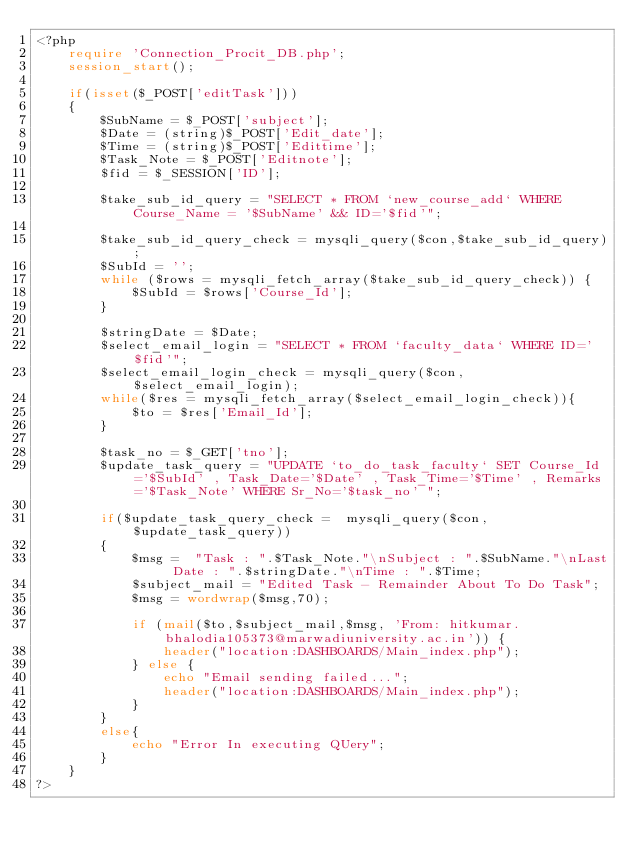Convert code to text. <code><loc_0><loc_0><loc_500><loc_500><_PHP_><?php
	require 'Connection_Procit_DB.php'; 
    session_start();

    if(isset($_POST['editTask']))
    {
    	$SubName = $_POST['subject'];
    	$Date = (string)$_POST['Edit_date'];
        $Time = (string)$_POST['Edittime'];
        $Task_Note = $_POST['Editnote'];
        $fid = $_SESSION['ID'];

        $take_sub_id_query = "SELECT * FROM `new_course_add` WHERE Course_Name = '$SubName' && ID='$fid'";

        $take_sub_id_query_check = mysqli_query($con,$take_sub_id_query);
        $SubId = '';
        while ($rows = mysqli_fetch_array($take_sub_id_query_check)) {
            $SubId = $rows['Course_Id'];
        }
        
        $stringDate = $Date;
        $select_email_login = "SELECT * FROM `faculty_data` WHERE ID='$fid'";
        $select_email_login_check = mysqli_query($con,$select_email_login);
        while($res = mysqli_fetch_array($select_email_login_check)){
            $to = $res['Email_Id'];
        }

        $task_no = $_GET['tno'];
    	$update_task_query = "UPDATE `to_do_task_faculty` SET Course_Id='$SubId' , Task_Date='$Date' , Task_Time='$Time' , Remarks='$Task_Note' WHERE Sr_No='$task_no' ";

    	if($update_task_query_check =  mysqli_query($con,$update_task_query))
    	{
            $msg =  "Task : ".$Task_Note."\nSubject : ".$SubName."\nLast Date : ".$stringDate."\nTime : ".$Time; 
            $subject_mail = "Edited Task - Remainder About To Do Task";
            $msg = wordwrap($msg,70);
            
            if (mail($to,$subject_mail,$msg, 'From: hitkumar.bhalodia105373@marwadiuniversity.ac.in')) {
                header("location:DASHBOARDS/Main_index.php");
            } else {
                echo "Email sending failed...";
                header("location:DASHBOARDS/Main_index.php");
            }
    	}
    	else{
    		echo "Error In executing QUery";
    	}
    }
?>

</code> 